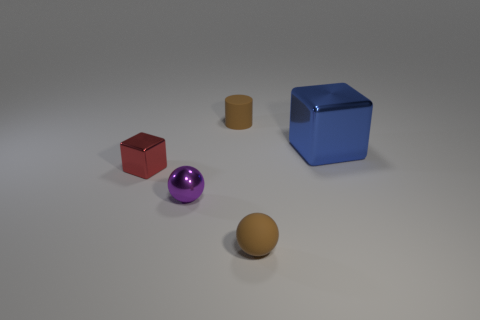Add 1 big green balls. How many objects exist? 6 Subtract all cylinders. How many objects are left? 4 Subtract 2 spheres. How many spheres are left? 0 Add 3 small purple things. How many small purple things are left? 4 Add 1 small brown cylinders. How many small brown cylinders exist? 2 Subtract 0 gray cubes. How many objects are left? 5 Subtract all cyan spheres. Subtract all purple cylinders. How many spheres are left? 2 Subtract all cyan spheres. How many red cubes are left? 1 Subtract all blue metallic cylinders. Subtract all blue objects. How many objects are left? 4 